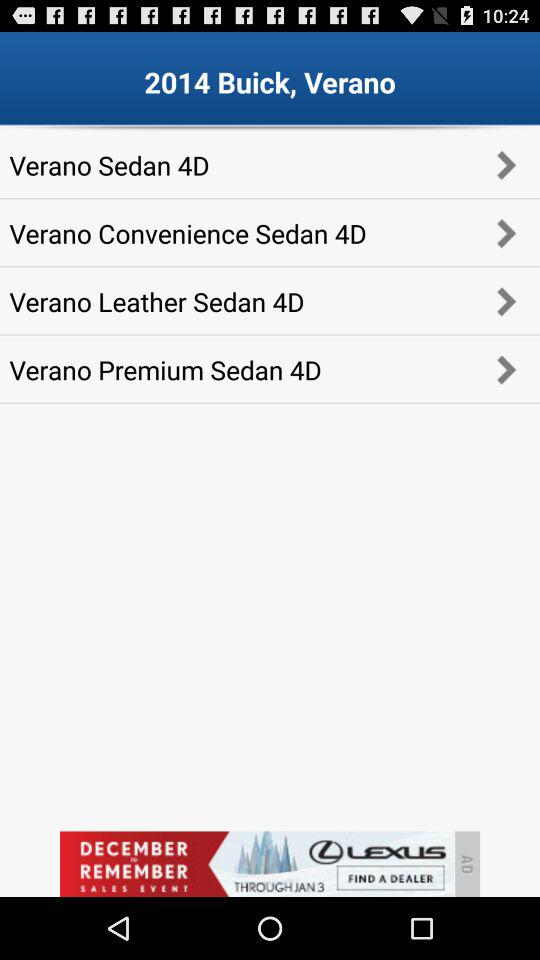What is the current location?
When the provided information is insufficient, respond with <no answer>. <no answer> 